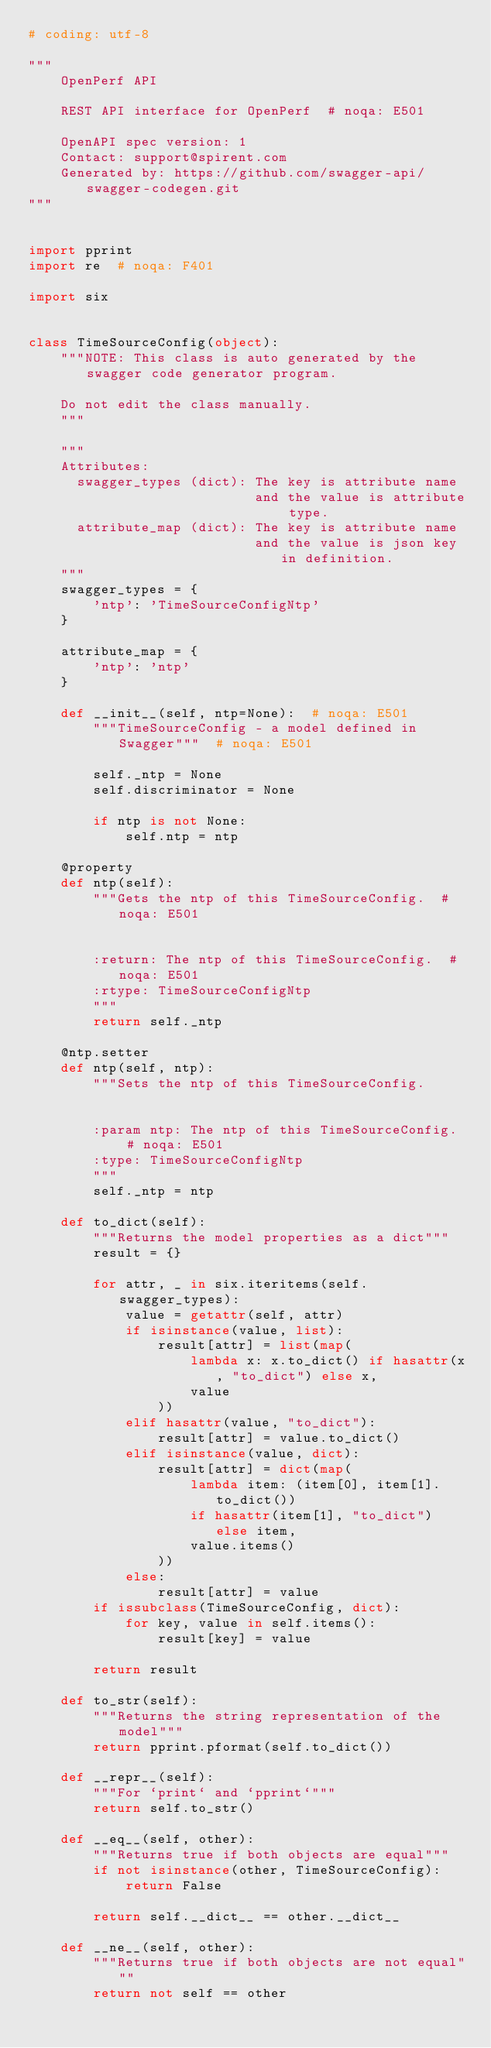<code> <loc_0><loc_0><loc_500><loc_500><_Python_># coding: utf-8

"""
    OpenPerf API

    REST API interface for OpenPerf  # noqa: E501

    OpenAPI spec version: 1
    Contact: support@spirent.com
    Generated by: https://github.com/swagger-api/swagger-codegen.git
"""


import pprint
import re  # noqa: F401

import six


class TimeSourceConfig(object):
    """NOTE: This class is auto generated by the swagger code generator program.

    Do not edit the class manually.
    """

    """
    Attributes:
      swagger_types (dict): The key is attribute name
                            and the value is attribute type.
      attribute_map (dict): The key is attribute name
                            and the value is json key in definition.
    """
    swagger_types = {
        'ntp': 'TimeSourceConfigNtp'
    }

    attribute_map = {
        'ntp': 'ntp'
    }

    def __init__(self, ntp=None):  # noqa: E501
        """TimeSourceConfig - a model defined in Swagger"""  # noqa: E501

        self._ntp = None
        self.discriminator = None

        if ntp is not None:
            self.ntp = ntp

    @property
    def ntp(self):
        """Gets the ntp of this TimeSourceConfig.  # noqa: E501


        :return: The ntp of this TimeSourceConfig.  # noqa: E501
        :rtype: TimeSourceConfigNtp
        """
        return self._ntp

    @ntp.setter
    def ntp(self, ntp):
        """Sets the ntp of this TimeSourceConfig.


        :param ntp: The ntp of this TimeSourceConfig.  # noqa: E501
        :type: TimeSourceConfigNtp
        """
        self._ntp = ntp

    def to_dict(self):
        """Returns the model properties as a dict"""
        result = {}

        for attr, _ in six.iteritems(self.swagger_types):
            value = getattr(self, attr)
            if isinstance(value, list):
                result[attr] = list(map(
                    lambda x: x.to_dict() if hasattr(x, "to_dict") else x,
                    value
                ))
            elif hasattr(value, "to_dict"):
                result[attr] = value.to_dict()
            elif isinstance(value, dict):
                result[attr] = dict(map(
                    lambda item: (item[0], item[1].to_dict())
                    if hasattr(item[1], "to_dict") else item,
                    value.items()
                ))
            else:
                result[attr] = value
        if issubclass(TimeSourceConfig, dict):
            for key, value in self.items():
                result[key] = value

        return result

    def to_str(self):
        """Returns the string representation of the model"""
        return pprint.pformat(self.to_dict())

    def __repr__(self):
        """For `print` and `pprint`"""
        return self.to_str()

    def __eq__(self, other):
        """Returns true if both objects are equal"""
        if not isinstance(other, TimeSourceConfig):
            return False

        return self.__dict__ == other.__dict__

    def __ne__(self, other):
        """Returns true if both objects are not equal"""
        return not self == other
</code> 